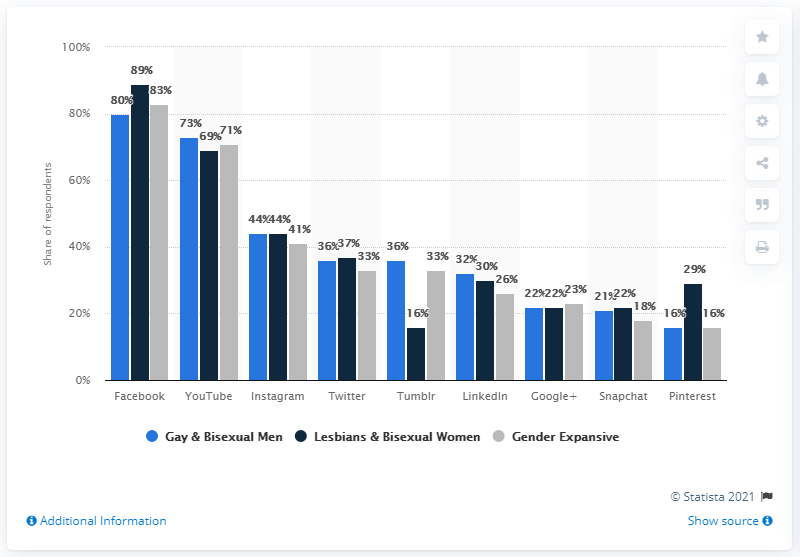Point out several critical features in this image. According to the provided information, it was disclosed that the most popular social media platform among gay/bisexual men and lesbian/bisexual women was Facebook. Among male respondents, 73% used Tumblr in the last 30 days. 